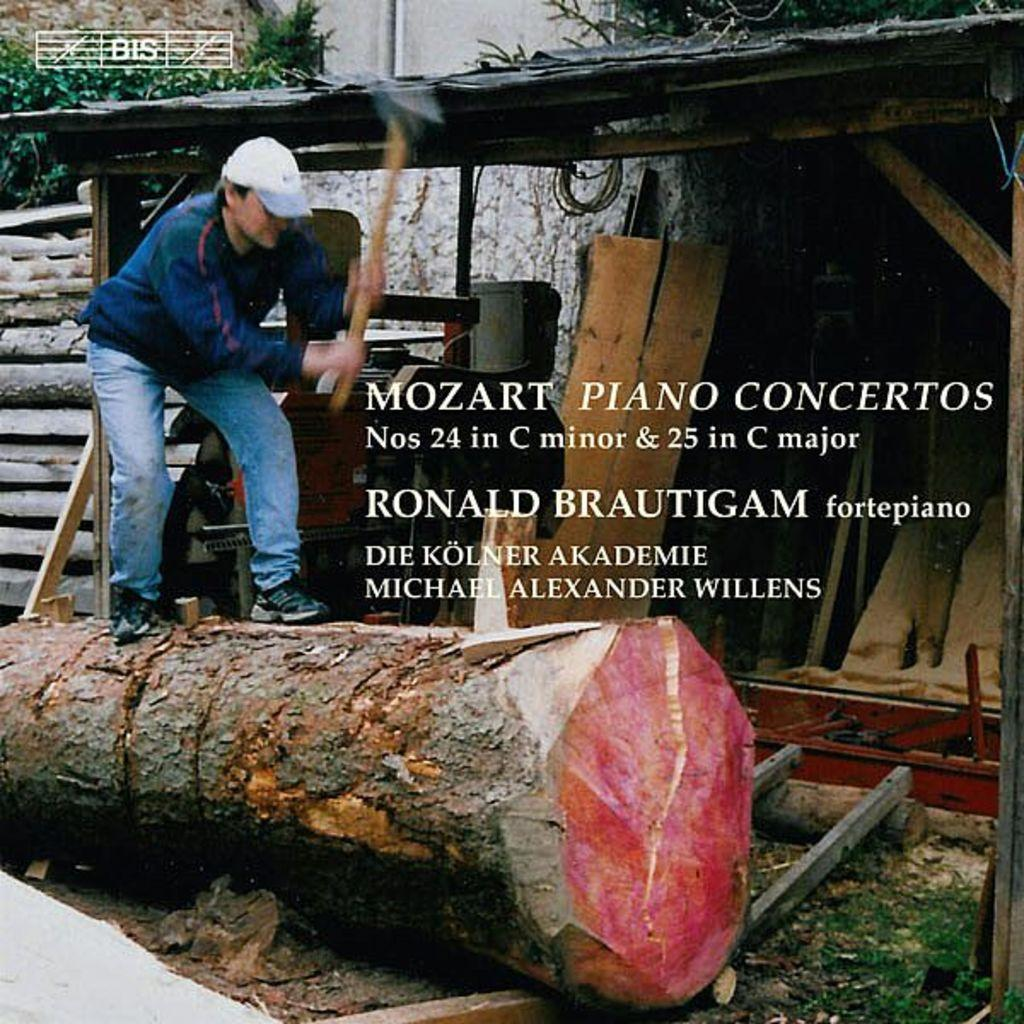What is the person doing in the image? The person is standing on wood beside a shed and holding an ax with their hands. What object is the person holding? The person is holding an ax. Is there any text present in the image? Yes, there is a text in the middle of the image. How many lizards can be seen crawling on the ax in the image? There are no lizards present in the image; the person is holding an ax. What type of wound is visible on the person's hand in the image? There is no wound visible on the person's hand in the image. 